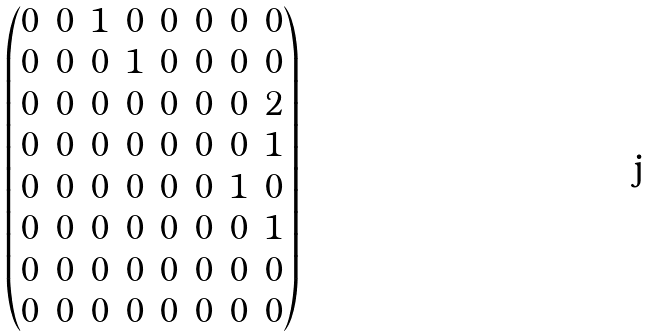<formula> <loc_0><loc_0><loc_500><loc_500>\begin{pmatrix} 0 & 0 & 1 & 0 & 0 & 0 & 0 & 0 \\ 0 & 0 & 0 & 1 & 0 & 0 & 0 & 0 \\ 0 & 0 & 0 & 0 & 0 & 0 & 0 & 2 \\ 0 & 0 & 0 & 0 & 0 & 0 & 0 & 1 \\ 0 & 0 & 0 & 0 & 0 & 0 & 1 & 0 \\ 0 & 0 & 0 & 0 & 0 & 0 & 0 & 1 \\ 0 & 0 & 0 & 0 & 0 & 0 & 0 & 0 \\ 0 & 0 & 0 & 0 & 0 & 0 & 0 & 0 \end{pmatrix}</formula> 